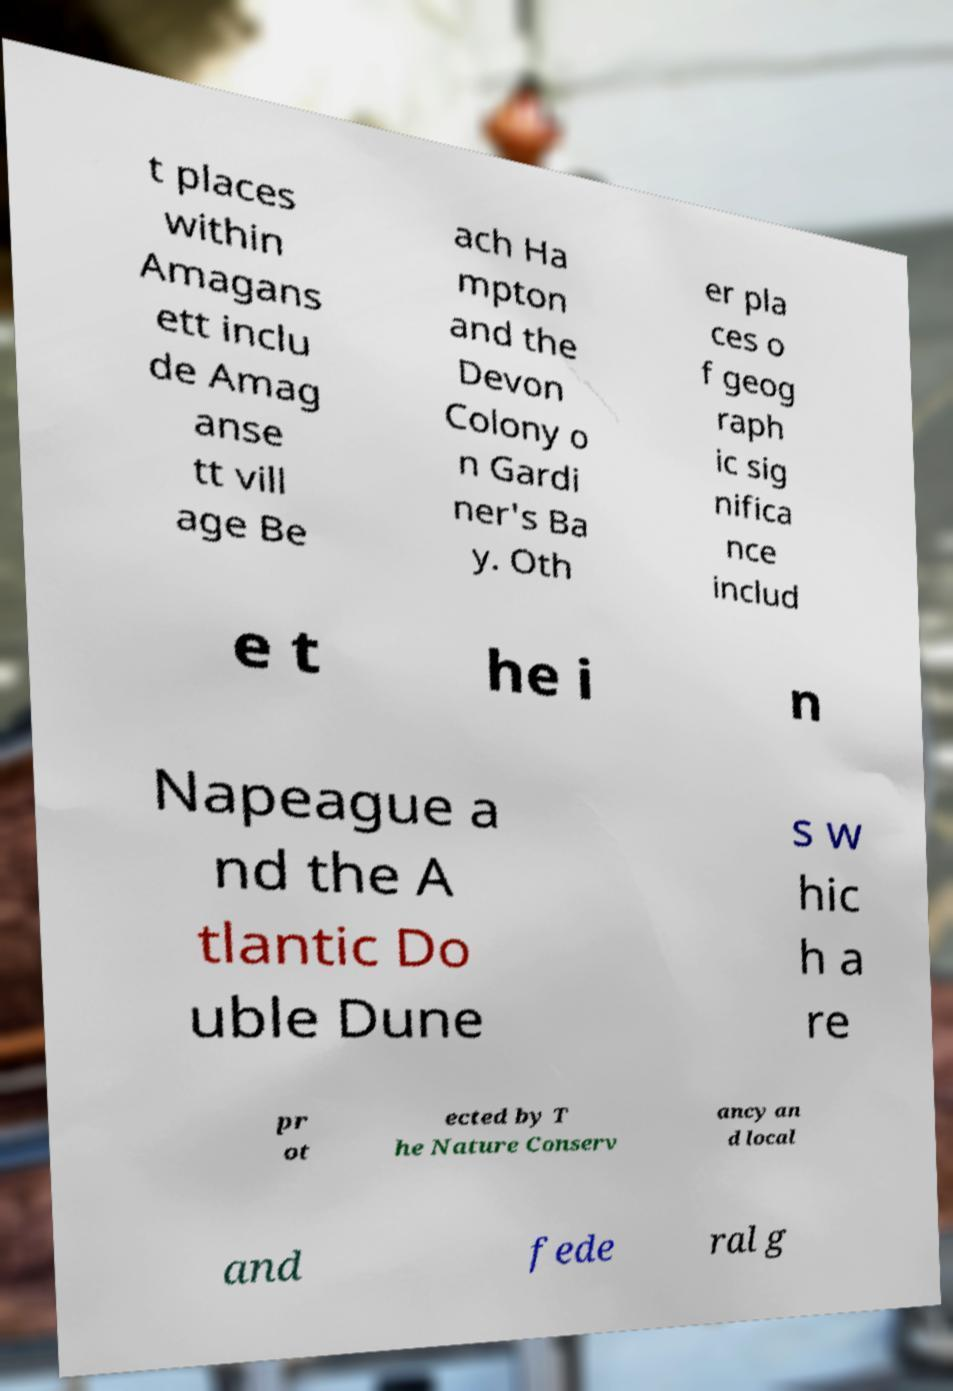What messages or text are displayed in this image? I need them in a readable, typed format. t places within Amagans ett inclu de Amag anse tt vill age Be ach Ha mpton and the Devon Colony o n Gardi ner's Ba y. Oth er pla ces o f geog raph ic sig nifica nce includ e t he i n Napeague a nd the A tlantic Do uble Dune s w hic h a re pr ot ected by T he Nature Conserv ancy an d local and fede ral g 